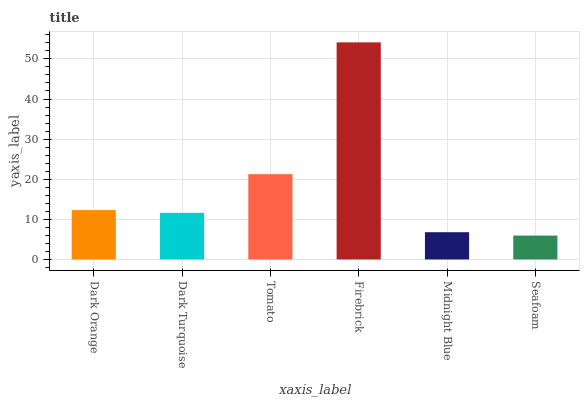Is Seafoam the minimum?
Answer yes or no. Yes. Is Firebrick the maximum?
Answer yes or no. Yes. Is Dark Turquoise the minimum?
Answer yes or no. No. Is Dark Turquoise the maximum?
Answer yes or no. No. Is Dark Orange greater than Dark Turquoise?
Answer yes or no. Yes. Is Dark Turquoise less than Dark Orange?
Answer yes or no. Yes. Is Dark Turquoise greater than Dark Orange?
Answer yes or no. No. Is Dark Orange less than Dark Turquoise?
Answer yes or no. No. Is Dark Orange the high median?
Answer yes or no. Yes. Is Dark Turquoise the low median?
Answer yes or no. Yes. Is Firebrick the high median?
Answer yes or no. No. Is Seafoam the low median?
Answer yes or no. No. 